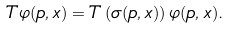Convert formula to latex. <formula><loc_0><loc_0><loc_500><loc_500>T \varphi ( p , x ) = T \left ( \sigma ( p , x ) \right ) \varphi ( p , x ) .</formula> 